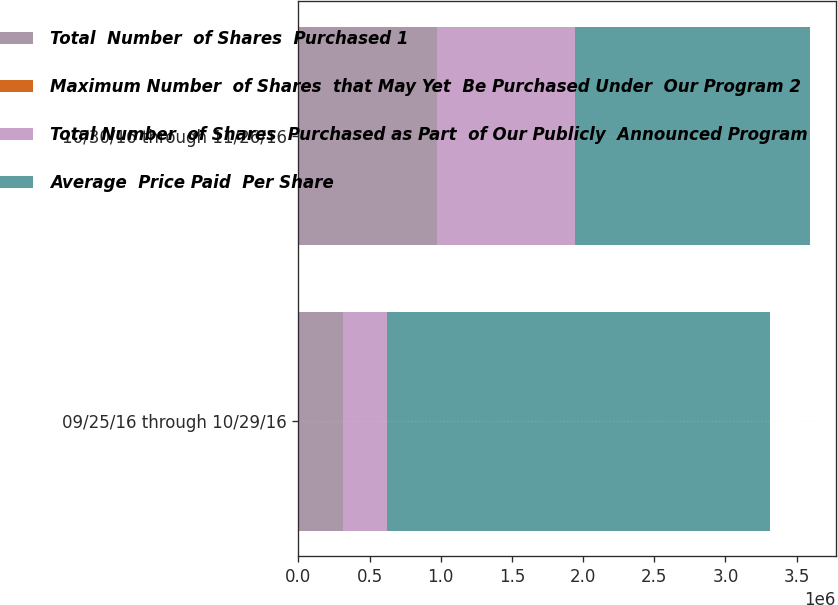<chart> <loc_0><loc_0><loc_500><loc_500><stacked_bar_chart><ecel><fcel>09/25/16 through 10/29/16<fcel>10/30/16 through 11/26/16<nl><fcel>Total  Number  of Shares  Purchased 1<fcel>310311<fcel>971031<nl><fcel>Maximum Number  of Shares  that May Yet  Be Purchased Under  Our Program 2<fcel>153.44<fcel>156.95<nl><fcel>Total Number  of Shares  Purchased as Part  of Our Publicly  Announced Program<fcel>310311<fcel>971031<nl><fcel>Average  Price Paid  Per Share<fcel>2.69511e+06<fcel>1.65366e+06<nl></chart> 